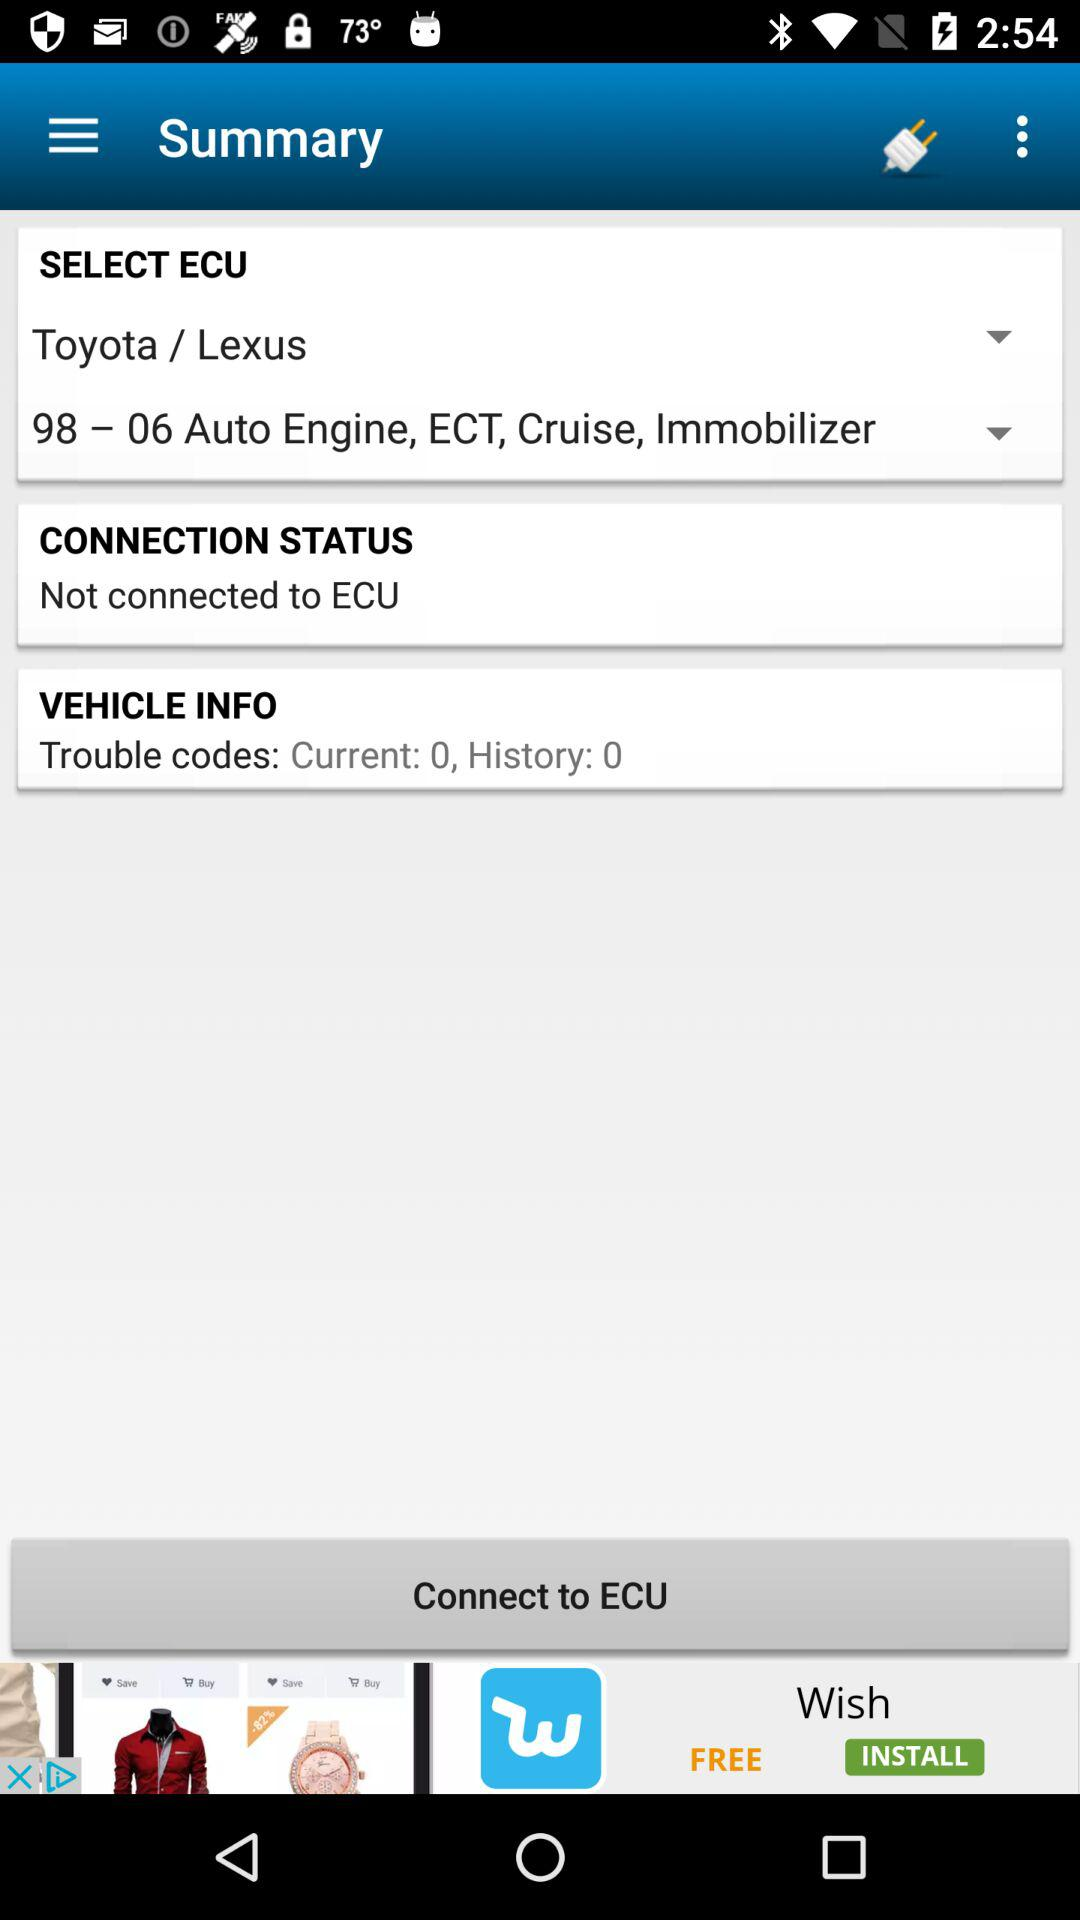How many trouble codes are displayed?
Answer the question using a single word or phrase. 0 